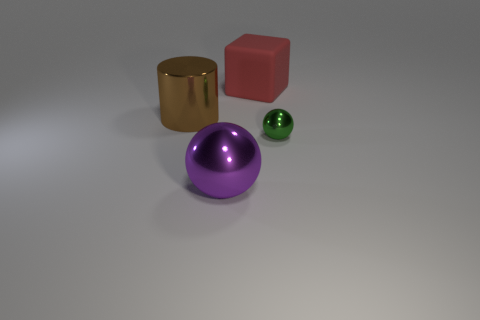Add 3 metal cylinders. How many objects exist? 7 Subtract all cubes. How many objects are left? 3 Add 1 red blocks. How many red blocks exist? 2 Subtract 0 brown balls. How many objects are left? 4 Subtract all cylinders. Subtract all purple metallic balls. How many objects are left? 2 Add 3 large metal balls. How many large metal balls are left? 4 